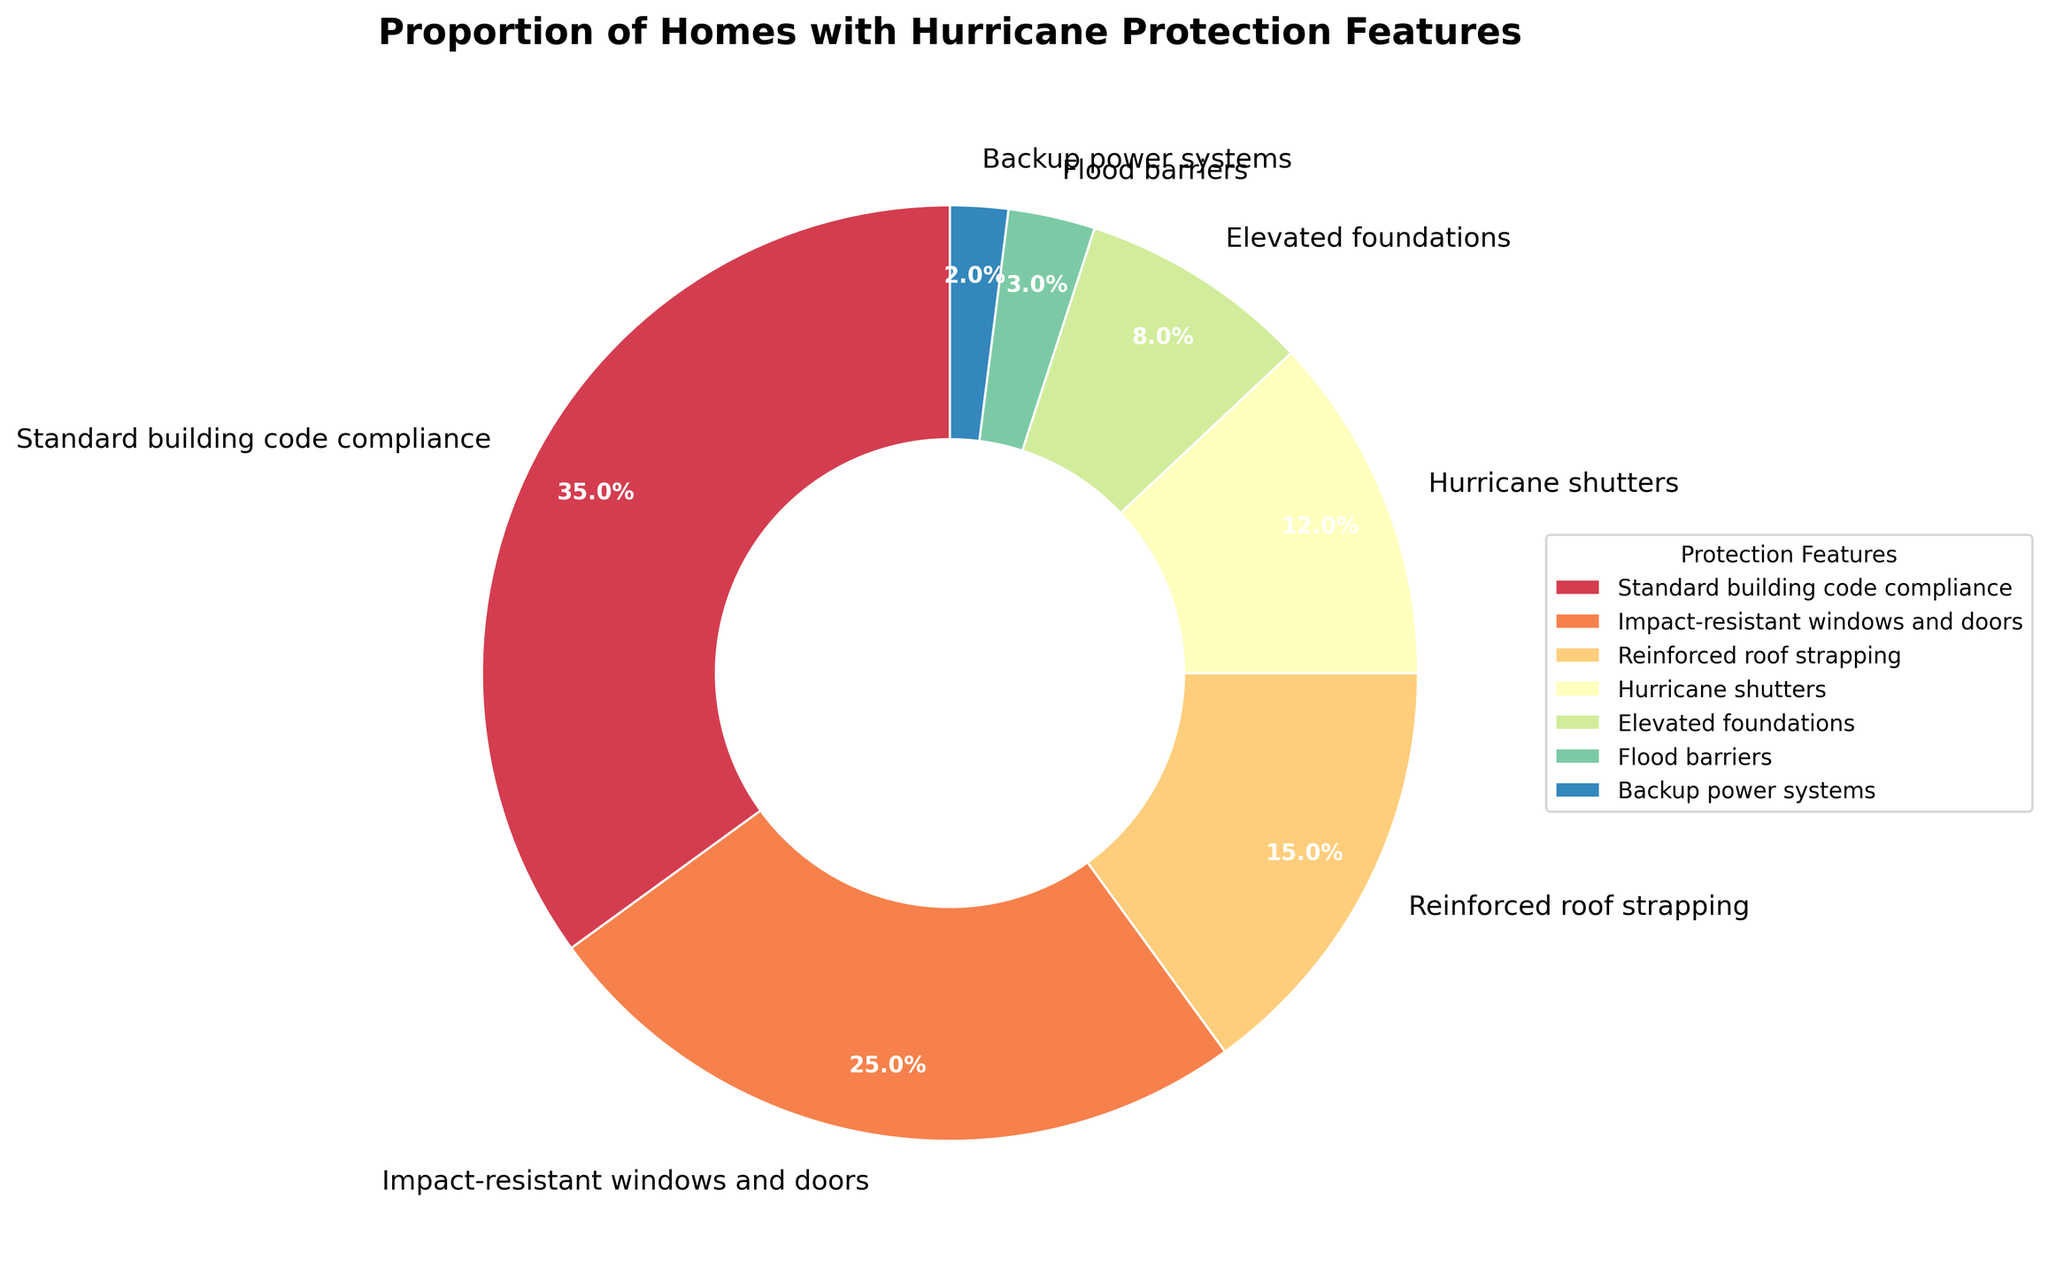What category has the highest proportion of homes with hurricane protection features? The slice labeled "Standard building code compliance" is the largest in the pie chart, which indicates that it has the highest proportion of homes with this feature.
Answer: Standard building code compliance Which two categories combined account for half of the homes? Adding the percentages of the two largest slices, "Standard building code compliance" (35%) and "Impact-resistant windows and doors" (25%), their total is 60%, which accounts for more than half of the homes.
Answer: Standard building code compliance and Impact-resistant windows and doors Which category has the smallest proportion of homes with hurricane protection features? The smallest slice in the pie chart is labeled "Backup power systems."
Answer: Backup power systems How much greater is the proportion of homes with "Impact-resistant windows and doors" compared to those with "Hurricane shutters"? The percentage for "Impact-resistant windows and doors" is 25%, and for "Hurricane shutters" it is 12%. The difference is 25% - 12% = 13%.
Answer: 13% Are there more homes with "Reinforced roof strapping" or "Elevated foundations"? The slice for "Reinforced roof strapping" is larger than that for "Elevated foundations," with 15% compared to 8%.
Answer: Reinforced roof strapping What is the total percentage for all categories that contribute less than 10% each? The categories with less than 10% are "Elevated foundations" (8%), "Flood barriers" (3%), and "Backup power systems" (2%). Their total percentage is 8% + 3% + 2% = 13%.
Answer: 13% If you add up the proportions of homes with "Standard building code compliance" and "Reinforced roof strapping," what percentage do you get? Adding the percentages of "Standard building code compliance" (35%) and "Reinforced roof strapping" (15%) results in 35% + 15% = 50%.
Answer: 50% Which category has a slightly higher proportion of homes, "Hurricane shutters" or "Elevated foundations"? Comparing the two slices, "Hurricane shutters" is 12%, and "Elevated foundations" is 8%. Hence, "Hurricane shutters" has a slightly higher proportion.
Answer: Hurricane shutters Is the proportion of homes with "Flood barriers" less than a third of total homes with "Reinforced roof strapping"? The percentage for "Flood barriers" is 3%, and a third of "Reinforced roof strapping" (15%) is 15% / 3 = 5%. Since 3% is less than 5%, the proportion of homes with "Flood barriers" is indeed less than a third of total homes with "Reinforced roof strapping".
Answer: Yes 